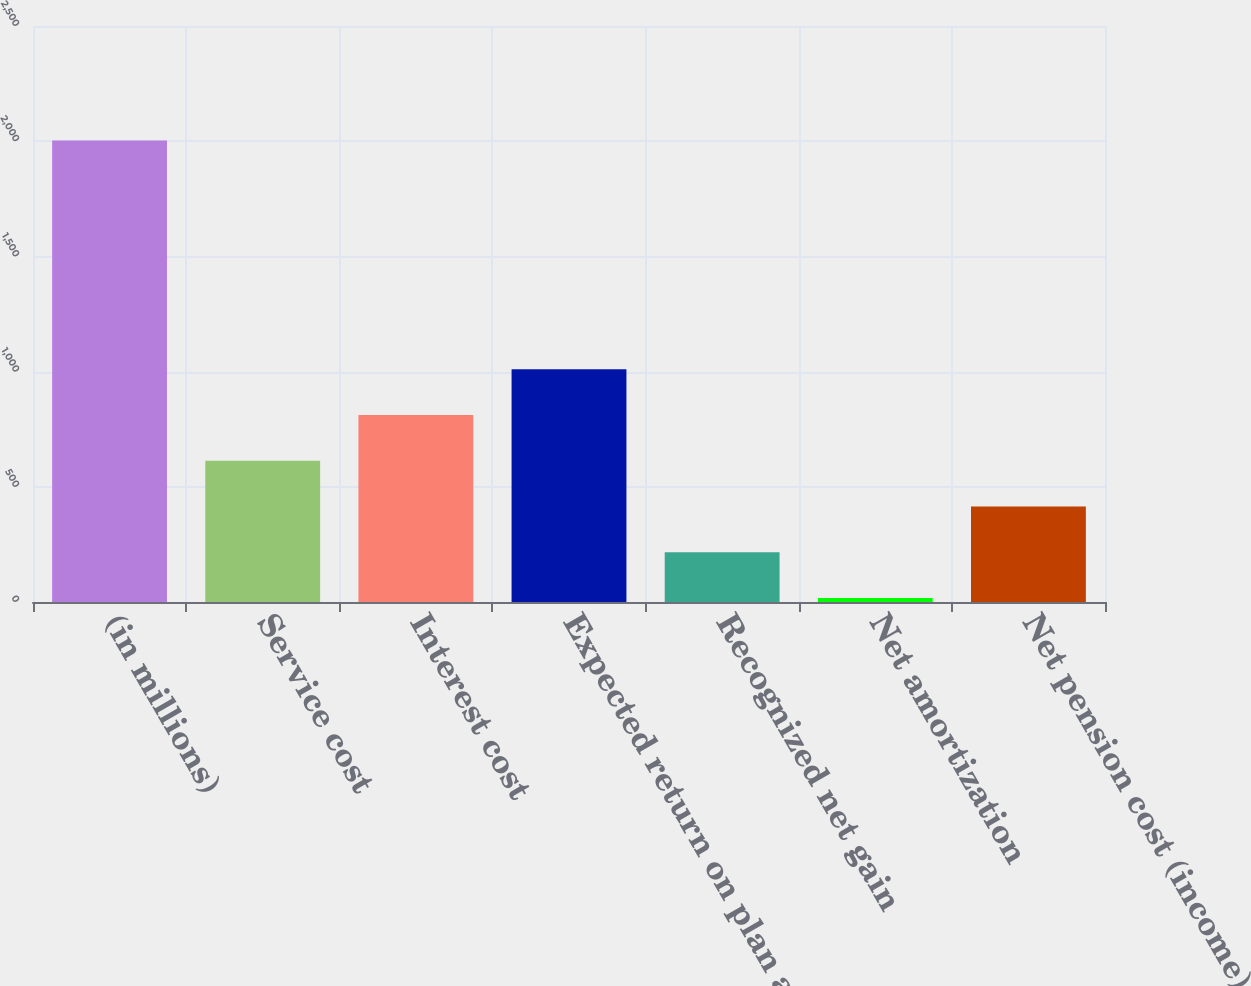Convert chart to OTSL. <chart><loc_0><loc_0><loc_500><loc_500><bar_chart><fcel>(in millions)<fcel>Service cost<fcel>Interest cost<fcel>Expected return on plan assets<fcel>Recognized net gain<fcel>Net amortization<fcel>Net pension cost (income)<nl><fcel>2003<fcel>612.8<fcel>811.4<fcel>1010<fcel>215.6<fcel>17<fcel>414.2<nl></chart> 